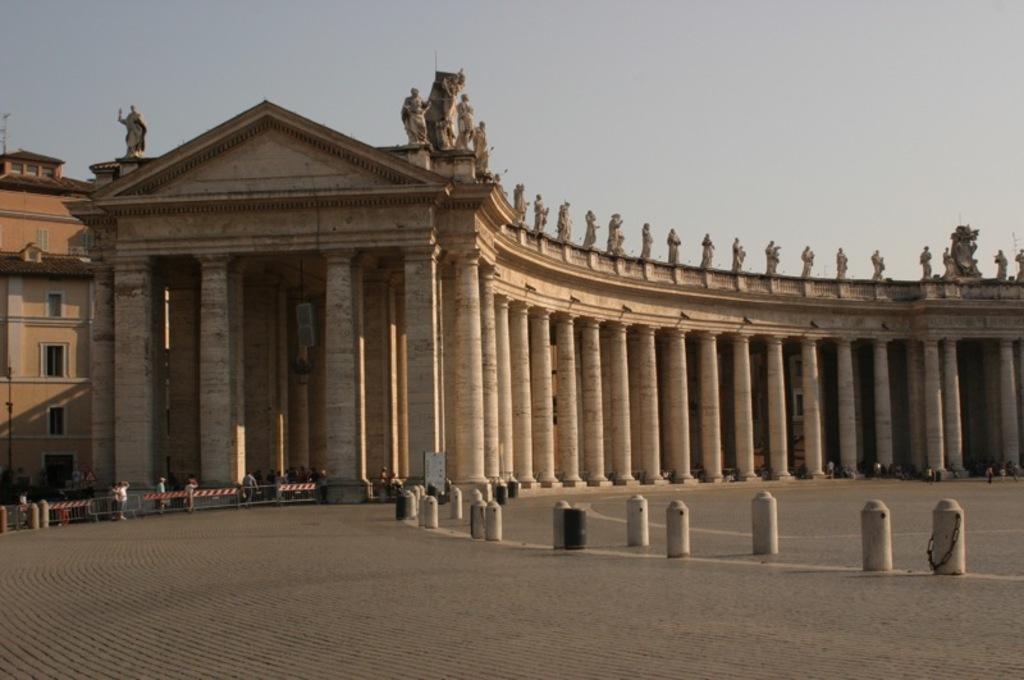How would you summarize this image in a sentence or two? In this picture we can see a few poles, barricades, some people and other objects on the path. We can see pillars, statues, windows and other objects on the buildings. There is the sky visible on top. 